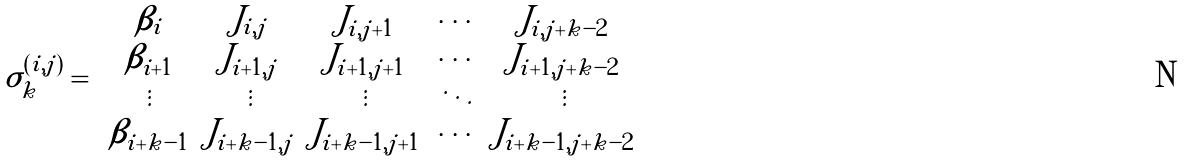Convert formula to latex. <formula><loc_0><loc_0><loc_500><loc_500>\sigma _ { k } ^ { ( i , j ) } = \left | \begin{array} { c c c c c } \beta _ { i } & J _ { i , j } & J _ { i , j + 1 } & \cdots & J _ { i , j + k - 2 } \\ \beta _ { i + 1 } & J _ { i + 1 , j } & J _ { i + 1 , j + 1 } & \cdots & J _ { i + 1 , j + k - 2 } \\ \vdots & \vdots & \vdots & \ddots & \vdots \\ \beta _ { i + k - 1 } & J _ { i + k - 1 , j } & J _ { i + k - 1 , j + 1 } & \cdots & J _ { i + k - 1 , j + k - 2 } \end{array} \right |</formula> 